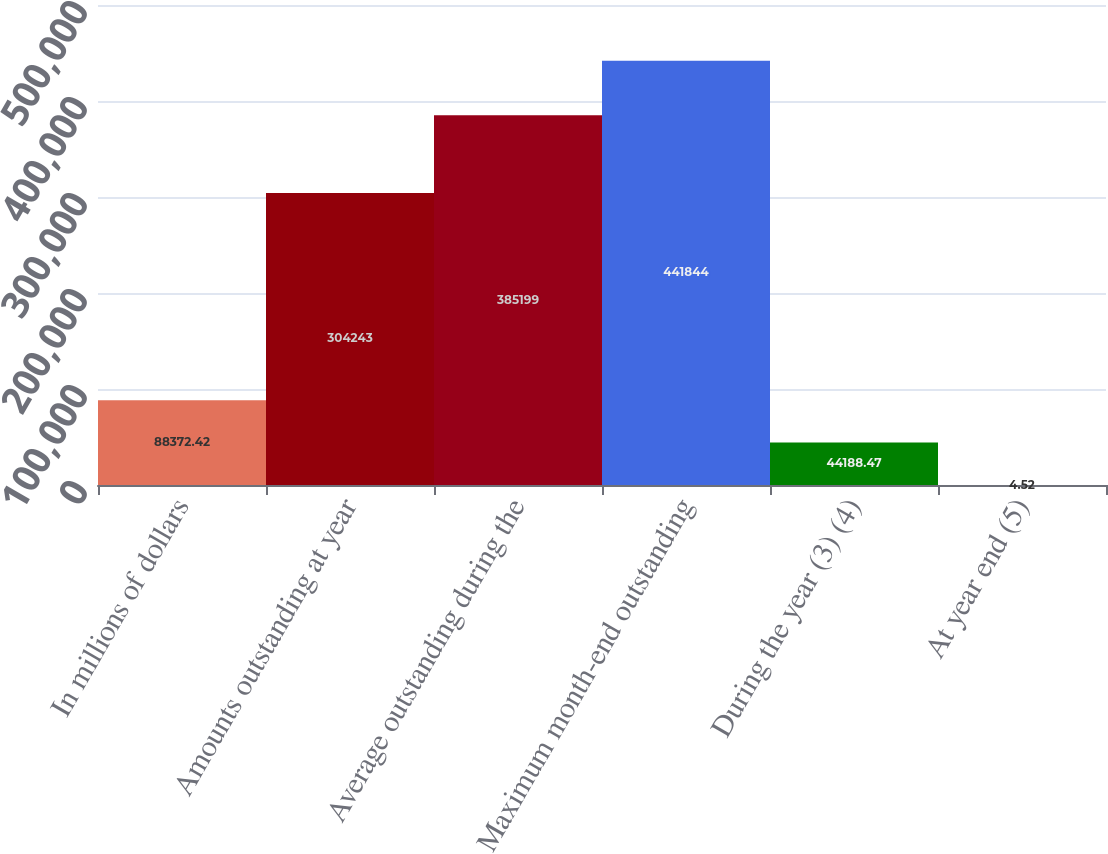Convert chart. <chart><loc_0><loc_0><loc_500><loc_500><bar_chart><fcel>In millions of dollars<fcel>Amounts outstanding at year<fcel>Average outstanding during the<fcel>Maximum month-end outstanding<fcel>During the year (3) (4)<fcel>At year end (5)<nl><fcel>88372.4<fcel>304243<fcel>385199<fcel>441844<fcel>44188.5<fcel>4.52<nl></chart> 